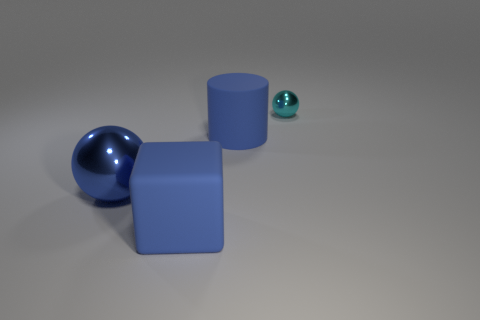Add 2 blue metallic objects. How many objects exist? 6 Subtract all cylinders. How many objects are left? 3 Subtract all blue metal objects. Subtract all cyan objects. How many objects are left? 2 Add 3 blue shiny objects. How many blue shiny objects are left? 4 Add 3 tiny cyan shiny cubes. How many tiny cyan shiny cubes exist? 3 Subtract 0 green cubes. How many objects are left? 4 